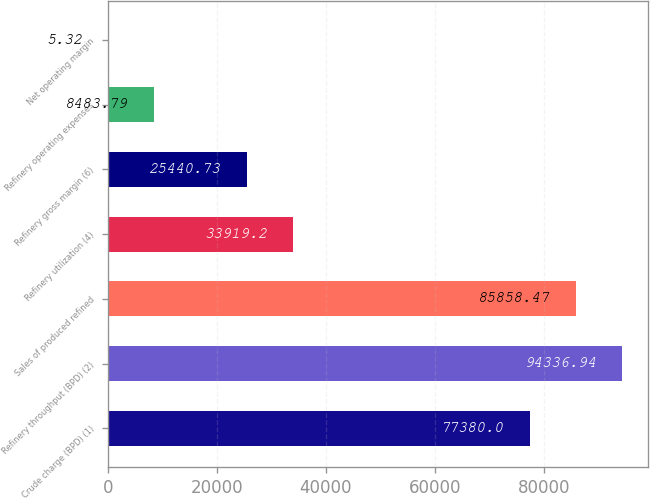Convert chart to OTSL. <chart><loc_0><loc_0><loc_500><loc_500><bar_chart><fcel>Crude charge (BPD) (1)<fcel>Refinery throughput (BPD) (2)<fcel>Sales of produced refined<fcel>Refinery utilization (4)<fcel>Refinery gross margin (6)<fcel>Refinery operating expenses<fcel>Net operating margin<nl><fcel>77380<fcel>94336.9<fcel>85858.5<fcel>33919.2<fcel>25440.7<fcel>8483.79<fcel>5.32<nl></chart> 